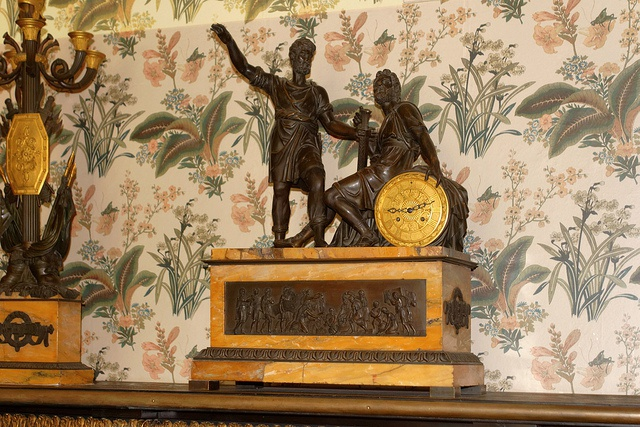Describe the objects in this image and their specific colors. I can see a clock in tan, orange, gold, and olive tones in this image. 